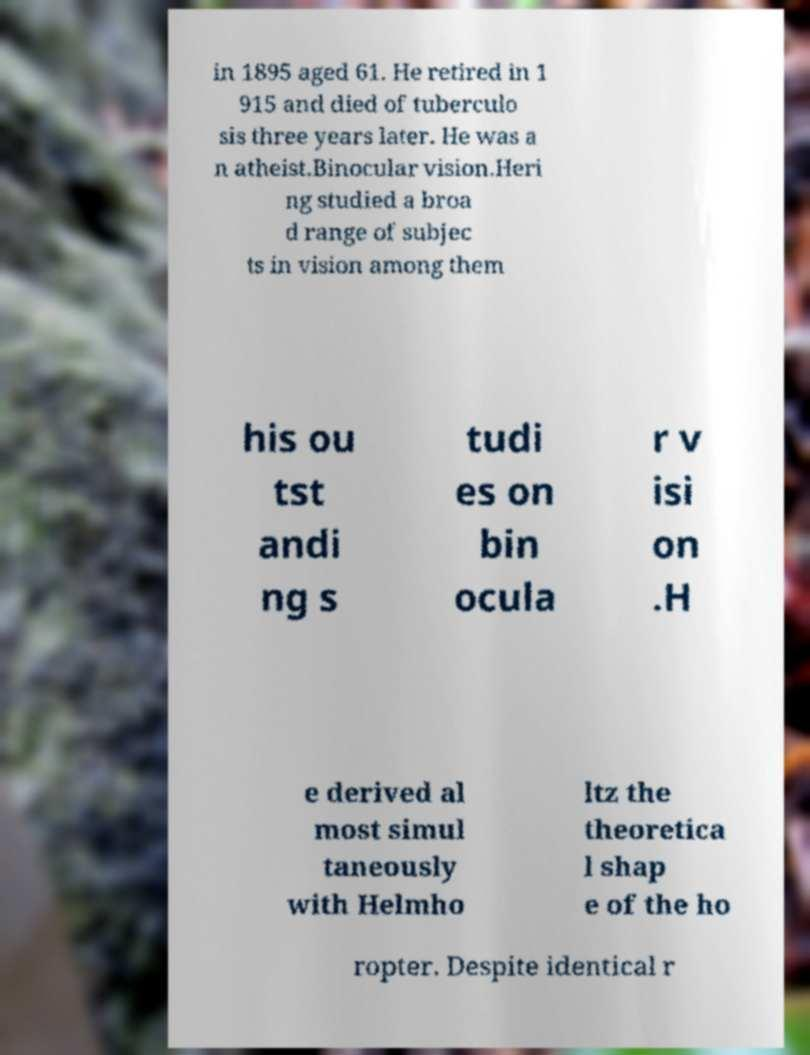Can you read and provide the text displayed in the image?This photo seems to have some interesting text. Can you extract and type it out for me? in 1895 aged 61. He retired in 1 915 and died of tuberculo sis three years later. He was a n atheist.Binocular vision.Heri ng studied a broa d range of subjec ts in vision among them his ou tst andi ng s tudi es on bin ocula r v isi on .H e derived al most simul taneously with Helmho ltz the theoretica l shap e of the ho ropter. Despite identical r 